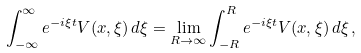<formula> <loc_0><loc_0><loc_500><loc_500>\int _ { - \infty } ^ { \infty } e ^ { - i \xi t } V ( x , \xi ) \, d \xi = \lim _ { R \to \infty } \int _ { - R } ^ { R } e ^ { - i \xi t } V ( x , \xi ) \, d \xi \, ,</formula> 